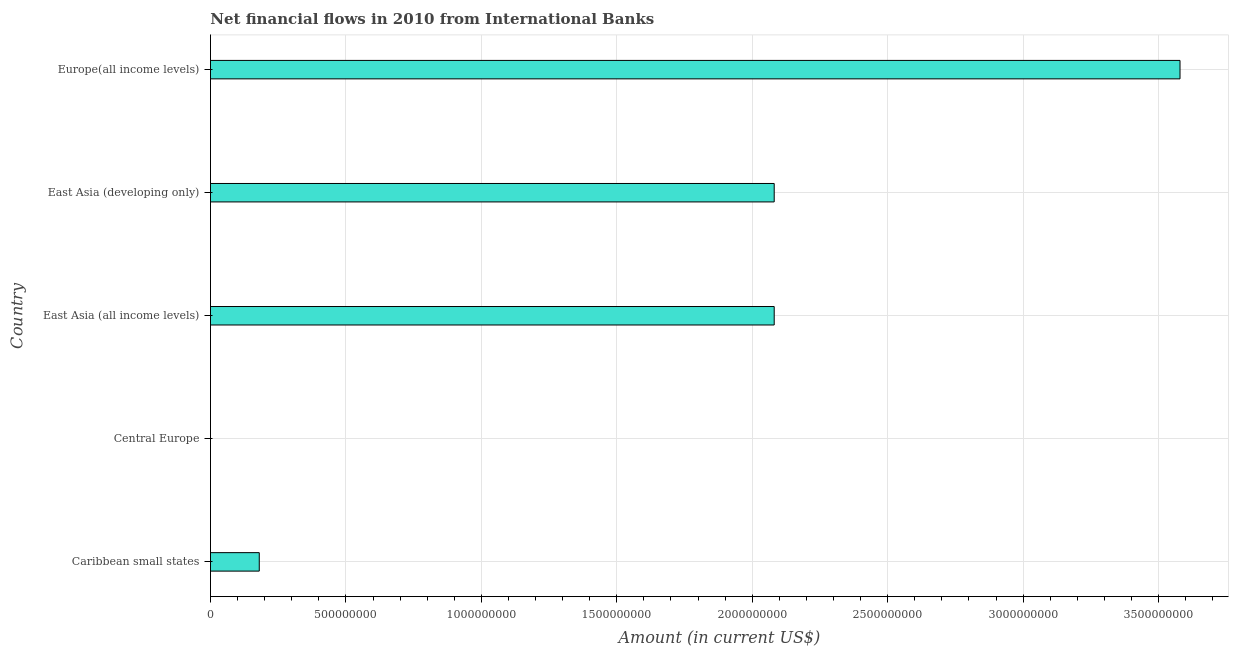What is the title of the graph?
Provide a short and direct response. Net financial flows in 2010 from International Banks. What is the label or title of the X-axis?
Your response must be concise. Amount (in current US$). What is the net financial flows from ibrd in Europe(all income levels)?
Offer a terse response. 3.58e+09. Across all countries, what is the maximum net financial flows from ibrd?
Your answer should be very brief. 3.58e+09. In which country was the net financial flows from ibrd maximum?
Ensure brevity in your answer.  Europe(all income levels). What is the sum of the net financial flows from ibrd?
Offer a very short reply. 7.92e+09. What is the average net financial flows from ibrd per country?
Give a very brief answer. 1.58e+09. What is the median net financial flows from ibrd?
Ensure brevity in your answer.  2.08e+09. In how many countries, is the net financial flows from ibrd greater than 2400000000 US$?
Give a very brief answer. 1. What is the ratio of the net financial flows from ibrd in East Asia (all income levels) to that in Europe(all income levels)?
Ensure brevity in your answer.  0.58. Is the difference between the net financial flows from ibrd in East Asia (all income levels) and Europe(all income levels) greater than the difference between any two countries?
Offer a terse response. No. What is the difference between the highest and the second highest net financial flows from ibrd?
Offer a very short reply. 1.50e+09. Is the sum of the net financial flows from ibrd in East Asia (developing only) and Europe(all income levels) greater than the maximum net financial flows from ibrd across all countries?
Your response must be concise. Yes. What is the difference between the highest and the lowest net financial flows from ibrd?
Offer a terse response. 3.58e+09. In how many countries, is the net financial flows from ibrd greater than the average net financial flows from ibrd taken over all countries?
Give a very brief answer. 3. How many bars are there?
Give a very brief answer. 4. Are all the bars in the graph horizontal?
Provide a short and direct response. Yes. How many countries are there in the graph?
Offer a terse response. 5. Are the values on the major ticks of X-axis written in scientific E-notation?
Your answer should be compact. No. What is the Amount (in current US$) of Caribbean small states?
Keep it short and to the point. 1.80e+08. What is the Amount (in current US$) in East Asia (all income levels)?
Offer a terse response. 2.08e+09. What is the Amount (in current US$) in East Asia (developing only)?
Give a very brief answer. 2.08e+09. What is the Amount (in current US$) in Europe(all income levels)?
Offer a very short reply. 3.58e+09. What is the difference between the Amount (in current US$) in Caribbean small states and East Asia (all income levels)?
Provide a short and direct response. -1.90e+09. What is the difference between the Amount (in current US$) in Caribbean small states and East Asia (developing only)?
Give a very brief answer. -1.90e+09. What is the difference between the Amount (in current US$) in Caribbean small states and Europe(all income levels)?
Offer a very short reply. -3.40e+09. What is the difference between the Amount (in current US$) in East Asia (all income levels) and East Asia (developing only)?
Make the answer very short. 0. What is the difference between the Amount (in current US$) in East Asia (all income levels) and Europe(all income levels)?
Provide a succinct answer. -1.50e+09. What is the difference between the Amount (in current US$) in East Asia (developing only) and Europe(all income levels)?
Provide a succinct answer. -1.50e+09. What is the ratio of the Amount (in current US$) in Caribbean small states to that in East Asia (all income levels)?
Provide a succinct answer. 0.09. What is the ratio of the Amount (in current US$) in Caribbean small states to that in East Asia (developing only)?
Your answer should be very brief. 0.09. What is the ratio of the Amount (in current US$) in Caribbean small states to that in Europe(all income levels)?
Offer a very short reply. 0.05. What is the ratio of the Amount (in current US$) in East Asia (all income levels) to that in East Asia (developing only)?
Offer a terse response. 1. What is the ratio of the Amount (in current US$) in East Asia (all income levels) to that in Europe(all income levels)?
Your response must be concise. 0.58. What is the ratio of the Amount (in current US$) in East Asia (developing only) to that in Europe(all income levels)?
Make the answer very short. 0.58. 